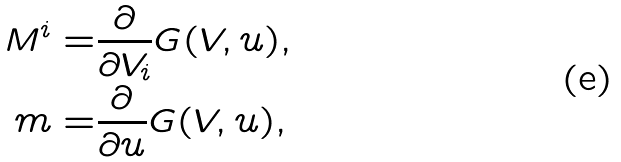Convert formula to latex. <formula><loc_0><loc_0><loc_500><loc_500>M ^ { i } = & \frac { \partial } { \partial V _ { i } } G ( V , u ) , \\ m = & \frac { \partial } { \partial u } G ( V , u ) ,</formula> 